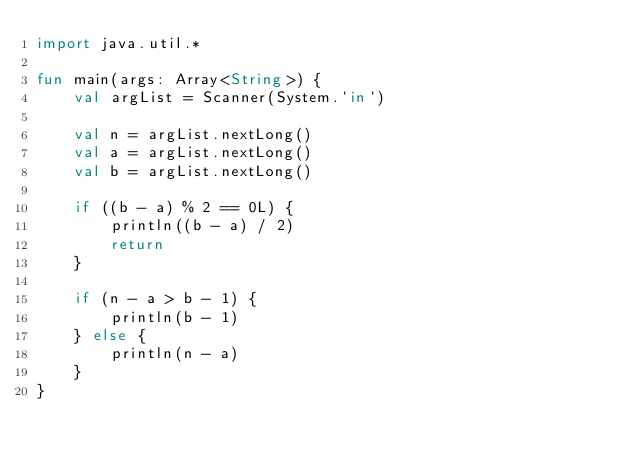<code> <loc_0><loc_0><loc_500><loc_500><_Kotlin_>import java.util.*

fun main(args: Array<String>) {
    val argList = Scanner(System.`in`)

    val n = argList.nextLong()
    val a = argList.nextLong()
    val b = argList.nextLong()

    if ((b - a) % 2 == 0L) {
        println((b - a) / 2)
        return
    }

    if (n - a > b - 1) {
        println(b - 1)
    } else {
        println(n - a)
    }
}
</code> 